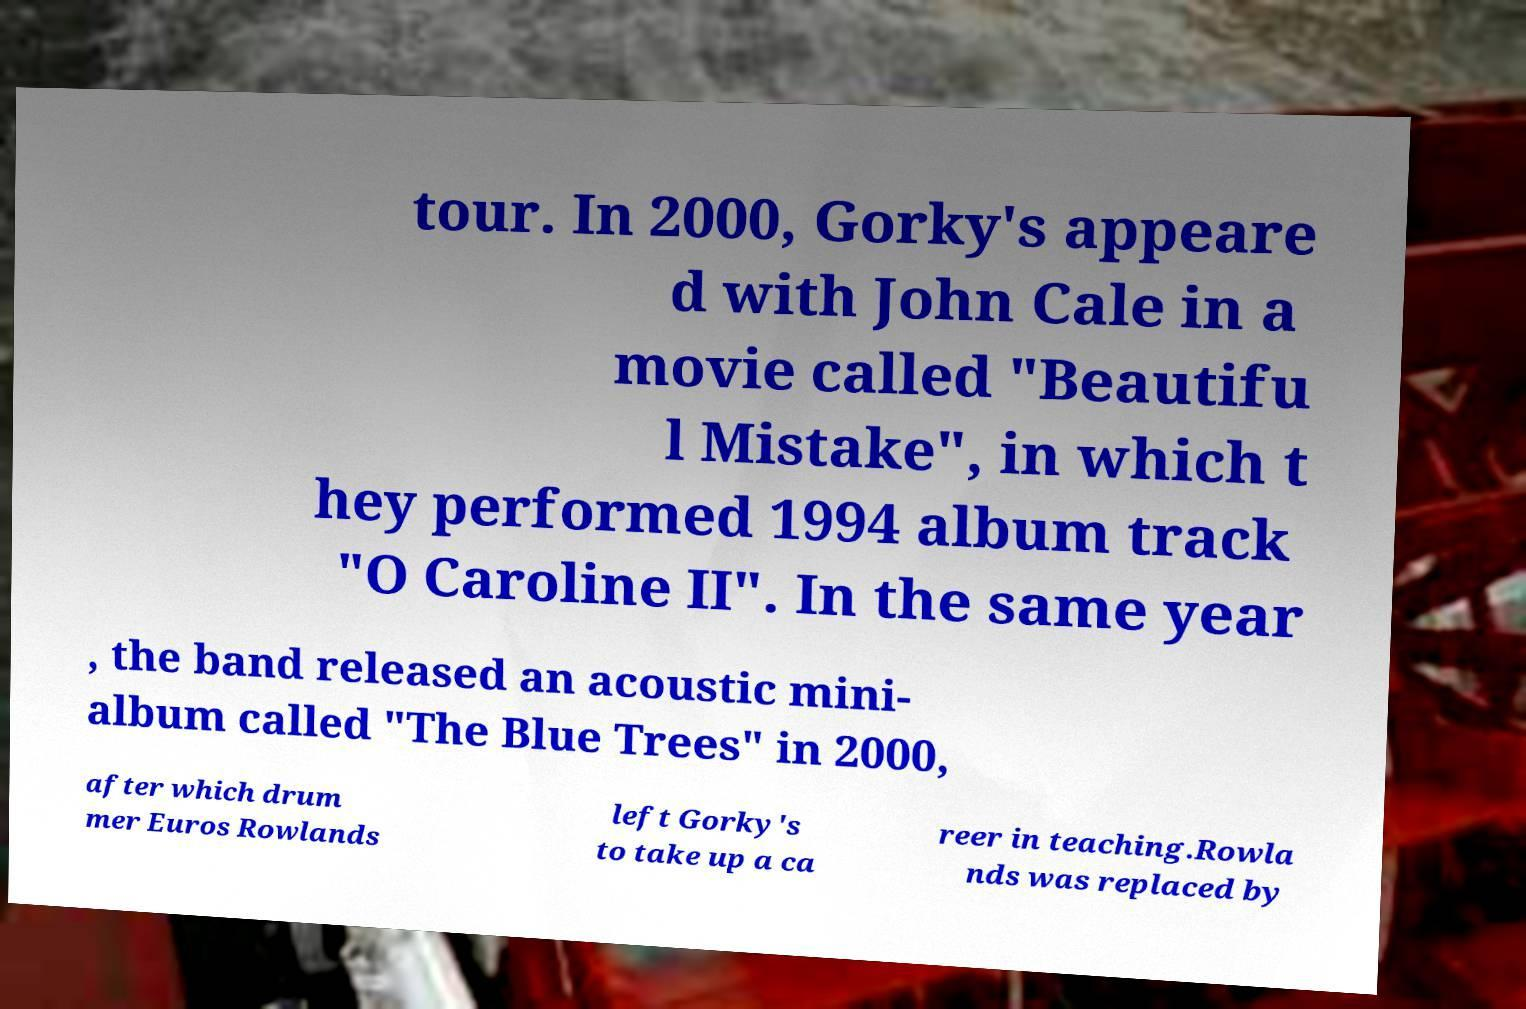Could you extract and type out the text from this image? tour. In 2000, Gorky's appeare d with John Cale in a movie called "Beautifu l Mistake", in which t hey performed 1994 album track "O Caroline II". In the same year , the band released an acoustic mini- album called "The Blue Trees" in 2000, after which drum mer Euros Rowlands left Gorky's to take up a ca reer in teaching.Rowla nds was replaced by 